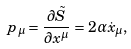<formula> <loc_0><loc_0><loc_500><loc_500>p _ { \mu } = \frac { \partial \tilde { S } } { \partial { x } ^ { \mu } } = 2 \alpha \dot { x } _ { \mu } ,</formula> 